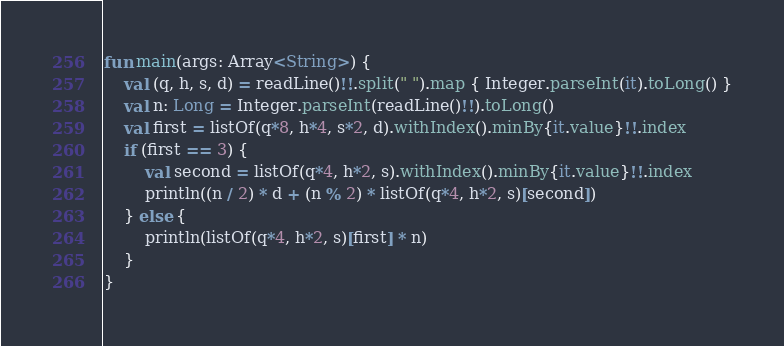Convert code to text. <code><loc_0><loc_0><loc_500><loc_500><_Kotlin_>fun main(args: Array<String>) {
    val (q, h, s, d) = readLine()!!.split(" ").map { Integer.parseInt(it).toLong() }
    val n: Long = Integer.parseInt(readLine()!!).toLong()
    val first = listOf(q*8, h*4, s*2, d).withIndex().minBy{it.value}!!.index
    if (first == 3) {
        val second = listOf(q*4, h*2, s).withIndex().minBy{it.value}!!.index
        println((n / 2) * d + (n % 2) * listOf(q*4, h*2, s)[second])
    } else {
        println(listOf(q*4, h*2, s)[first] * n)
    }
}</code> 